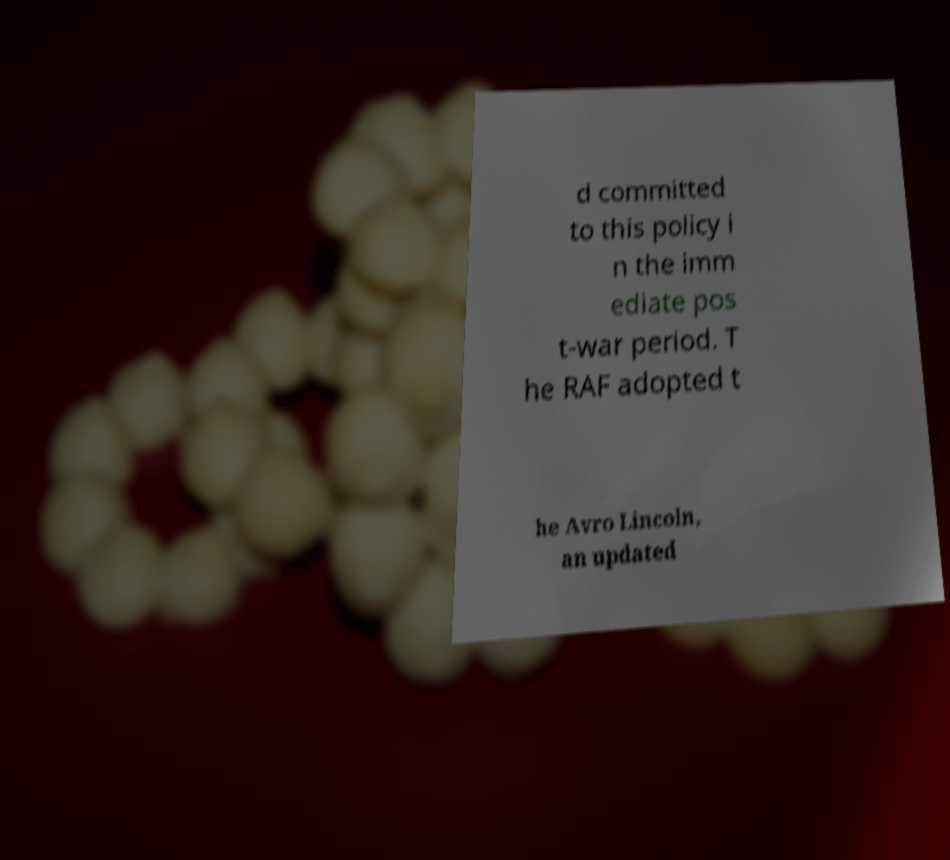Can you accurately transcribe the text from the provided image for me? d committed to this policy i n the imm ediate pos t-war period. T he RAF adopted t he Avro Lincoln, an updated 